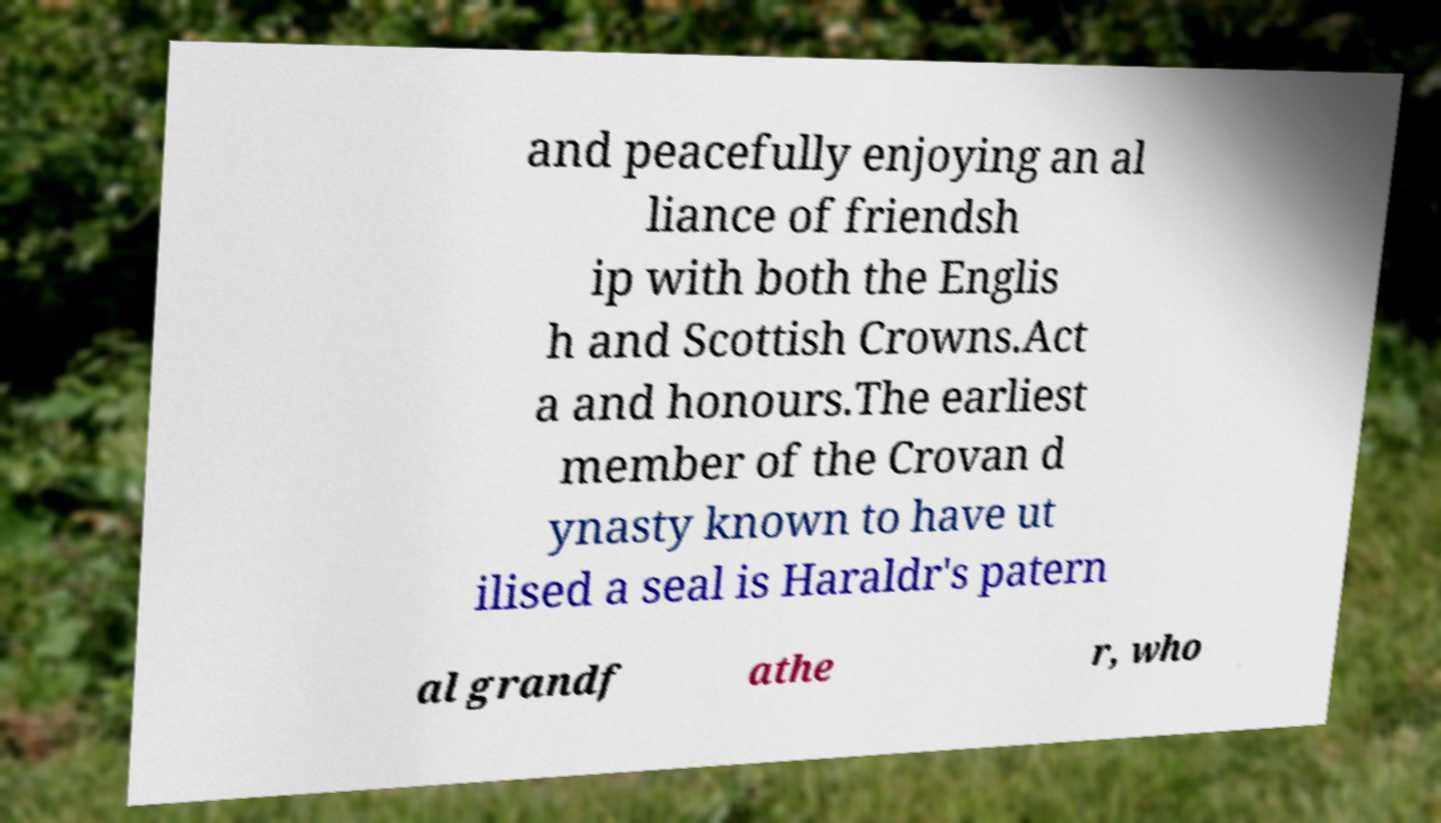What messages or text are displayed in this image? I need them in a readable, typed format. and peacefully enjoying an al liance of friendsh ip with both the Englis h and Scottish Crowns.Act a and honours.The earliest member of the Crovan d ynasty known to have ut ilised a seal is Haraldr's patern al grandf athe r, who 